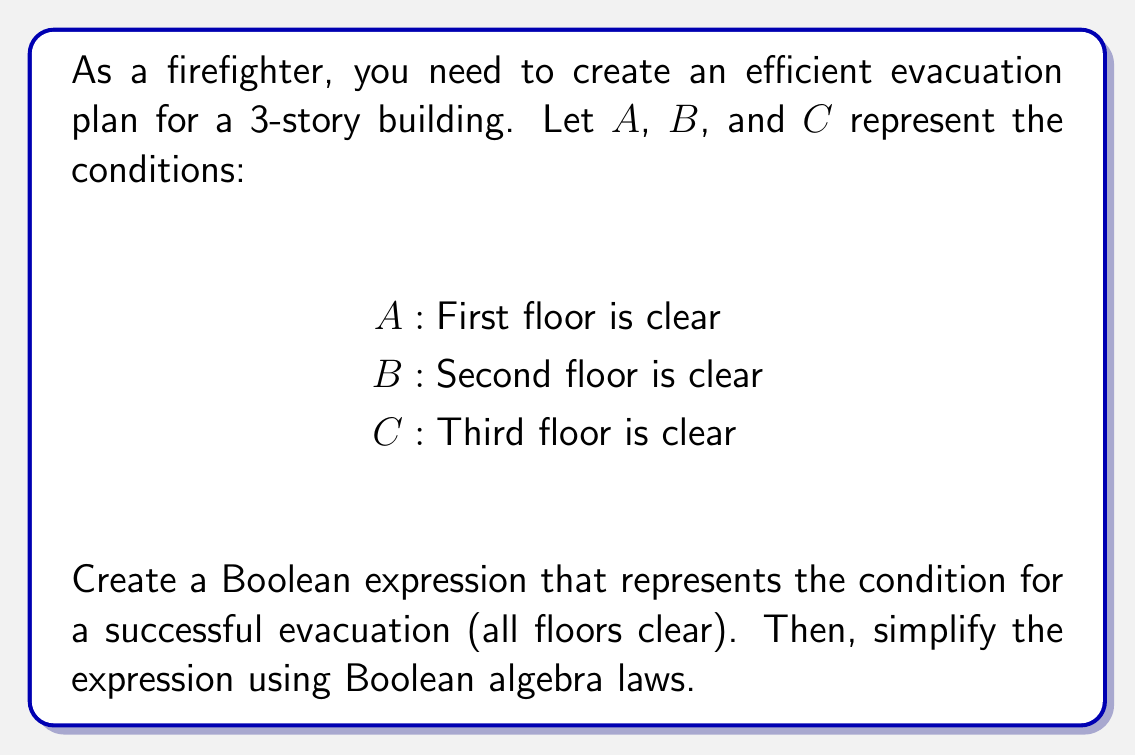Can you solve this math problem? 1. To represent a successful evacuation, all floors must be clear. This is represented by the logical AND of all conditions:

   $E = A \land B \land C$

2. This expression is already in its simplest form, as it directly represents the requirement that all floors must be clear for a successful evacuation.

3. We can verify this using the idempotent law and the commutative law of Boolean algebra:

   $E = A \land B \land C$
   $= (A \land A) \land (B \land B) \land (C \land C)$ (idempotent law)
   $= A \land B \land C$ (simplification)

4. The order of the terms doesn't matter due to the commutative law:

   $E = A \land B \land C = B \land A \land C = C \land A \land B$, etc.

5. This Boolean expression efficiently represents the evacuation plan, as it clearly indicates that all floors must be clear for the evacuation to be considered successful.
Answer: $E = A \land B \land C$ 